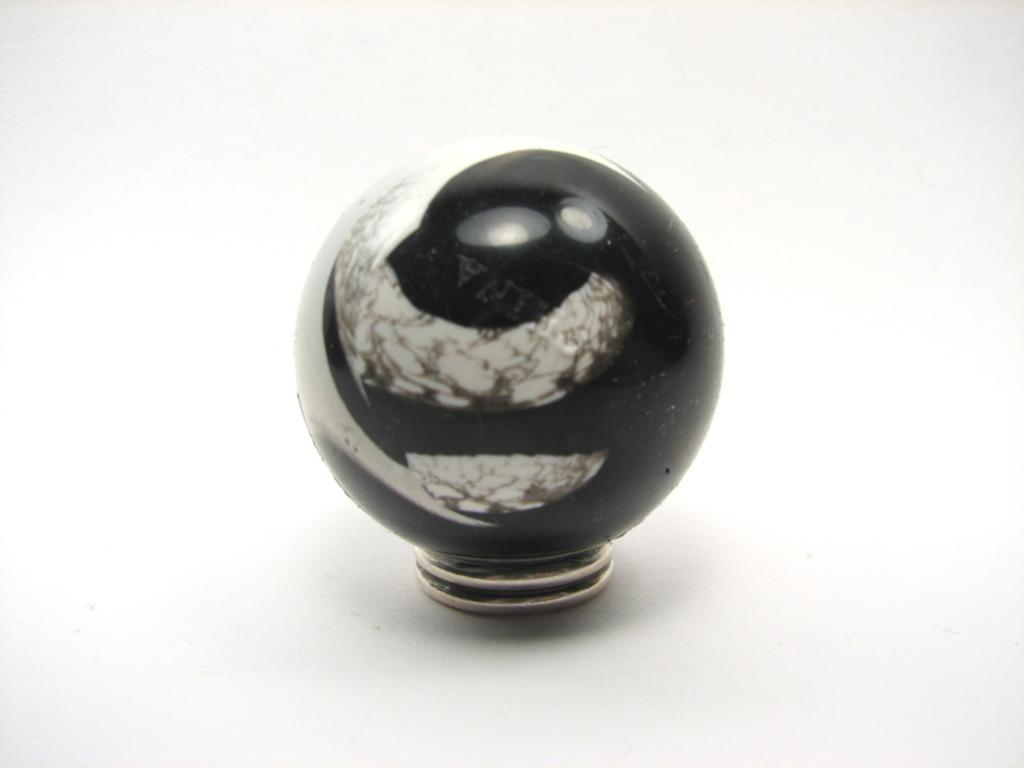What object can be seen on a surface in the image? There is a door knob on a surface in the image. What is the purpose of the object on the surface? The door knob is used for opening or closing a door. Can you describe the appearance of the door knob? The door knob appears to be a round, metallic handle. What grade does the door knob receive for its performance in the image? The door knob's performance cannot be graded, as it is an inanimate object and not capable of performing tasks or achieving a grade. 